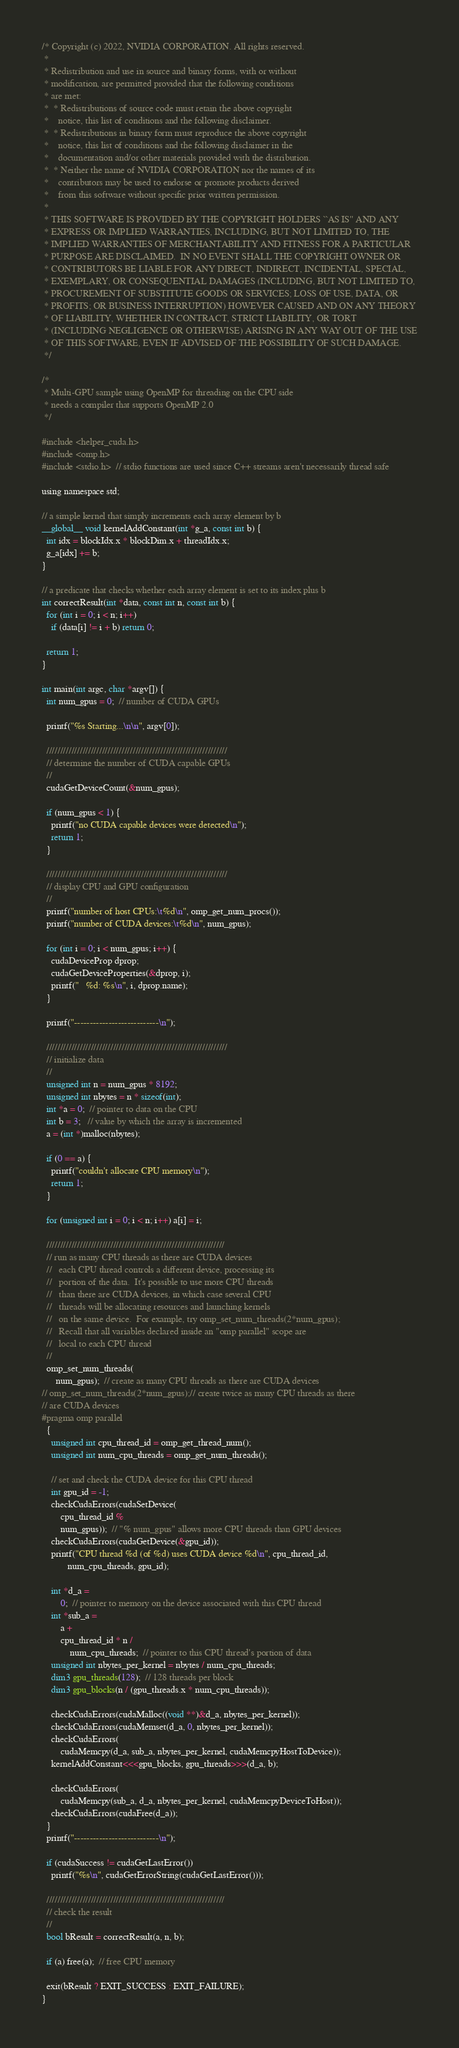<code> <loc_0><loc_0><loc_500><loc_500><_Cuda_>/* Copyright (c) 2022, NVIDIA CORPORATION. All rights reserved.
 *
 * Redistribution and use in source and binary forms, with or without
 * modification, are permitted provided that the following conditions
 * are met:
 *  * Redistributions of source code must retain the above copyright
 *    notice, this list of conditions and the following disclaimer.
 *  * Redistributions in binary form must reproduce the above copyright
 *    notice, this list of conditions and the following disclaimer in the
 *    documentation and/or other materials provided with the distribution.
 *  * Neither the name of NVIDIA CORPORATION nor the names of its
 *    contributors may be used to endorse or promote products derived
 *    from this software without specific prior written permission.
 *
 * THIS SOFTWARE IS PROVIDED BY THE COPYRIGHT HOLDERS ``AS IS'' AND ANY
 * EXPRESS OR IMPLIED WARRANTIES, INCLUDING, BUT NOT LIMITED TO, THE
 * IMPLIED WARRANTIES OF MERCHANTABILITY AND FITNESS FOR A PARTICULAR
 * PURPOSE ARE DISCLAIMED.  IN NO EVENT SHALL THE COPYRIGHT OWNER OR
 * CONTRIBUTORS BE LIABLE FOR ANY DIRECT, INDIRECT, INCIDENTAL, SPECIAL,
 * EXEMPLARY, OR CONSEQUENTIAL DAMAGES (INCLUDING, BUT NOT LIMITED TO,
 * PROCUREMENT OF SUBSTITUTE GOODS OR SERVICES; LOSS OF USE, DATA, OR
 * PROFITS; OR BUSINESS INTERRUPTION) HOWEVER CAUSED AND ON ANY THEORY
 * OF LIABILITY, WHETHER IN CONTRACT, STRICT LIABILITY, OR TORT
 * (INCLUDING NEGLIGENCE OR OTHERWISE) ARISING IN ANY WAY OUT OF THE USE
 * OF THIS SOFTWARE, EVEN IF ADVISED OF THE POSSIBILITY OF SUCH DAMAGE.
 */

/*
 * Multi-GPU sample using OpenMP for threading on the CPU side
 * needs a compiler that supports OpenMP 2.0
 */

#include <helper_cuda.h>
#include <omp.h>
#include <stdio.h>  // stdio functions are used since C++ streams aren't necessarily thread safe

using namespace std;

// a simple kernel that simply increments each array element by b
__global__ void kernelAddConstant(int *g_a, const int b) {
  int idx = blockIdx.x * blockDim.x + threadIdx.x;
  g_a[idx] += b;
}

// a predicate that checks whether each array element is set to its index plus b
int correctResult(int *data, const int n, const int b) {
  for (int i = 0; i < n; i++)
    if (data[i] != i + b) return 0;

  return 1;
}

int main(int argc, char *argv[]) {
  int num_gpus = 0;  // number of CUDA GPUs

  printf("%s Starting...\n\n", argv[0]);

  /////////////////////////////////////////////////////////////////
  // determine the number of CUDA capable GPUs
  //
  cudaGetDeviceCount(&num_gpus);

  if (num_gpus < 1) {
    printf("no CUDA capable devices were detected\n");
    return 1;
  }

  /////////////////////////////////////////////////////////////////
  // display CPU and GPU configuration
  //
  printf("number of host CPUs:\t%d\n", omp_get_num_procs());
  printf("number of CUDA devices:\t%d\n", num_gpus);

  for (int i = 0; i < num_gpus; i++) {
    cudaDeviceProp dprop;
    cudaGetDeviceProperties(&dprop, i);
    printf("   %d: %s\n", i, dprop.name);
  }

  printf("---------------------------\n");

  /////////////////////////////////////////////////////////////////
  // initialize data
  //
  unsigned int n = num_gpus * 8192;
  unsigned int nbytes = n * sizeof(int);
  int *a = 0;  // pointer to data on the CPU
  int b = 3;   // value by which the array is incremented
  a = (int *)malloc(nbytes);

  if (0 == a) {
    printf("couldn't allocate CPU memory\n");
    return 1;
  }

  for (unsigned int i = 0; i < n; i++) a[i] = i;

  ////////////////////////////////////////////////////////////////
  // run as many CPU threads as there are CUDA devices
  //   each CPU thread controls a different device, processing its
  //   portion of the data.  It's possible to use more CPU threads
  //   than there are CUDA devices, in which case several CPU
  //   threads will be allocating resources and launching kernels
  //   on the same device.  For example, try omp_set_num_threads(2*num_gpus);
  //   Recall that all variables declared inside an "omp parallel" scope are
  //   local to each CPU thread
  //
  omp_set_num_threads(
      num_gpus);  // create as many CPU threads as there are CUDA devices
// omp_set_num_threads(2*num_gpus);// create twice as many CPU threads as there
// are CUDA devices
#pragma omp parallel
  {
    unsigned int cpu_thread_id = omp_get_thread_num();
    unsigned int num_cpu_threads = omp_get_num_threads();

    // set and check the CUDA device for this CPU thread
    int gpu_id = -1;
    checkCudaErrors(cudaSetDevice(
        cpu_thread_id %
        num_gpus));  // "% num_gpus" allows more CPU threads than GPU devices
    checkCudaErrors(cudaGetDevice(&gpu_id));
    printf("CPU thread %d (of %d) uses CUDA device %d\n", cpu_thread_id,
           num_cpu_threads, gpu_id);

    int *d_a =
        0;  // pointer to memory on the device associated with this CPU thread
    int *sub_a =
        a +
        cpu_thread_id * n /
            num_cpu_threads;  // pointer to this CPU thread's portion of data
    unsigned int nbytes_per_kernel = nbytes / num_cpu_threads;
    dim3 gpu_threads(128);  // 128 threads per block
    dim3 gpu_blocks(n / (gpu_threads.x * num_cpu_threads));

    checkCudaErrors(cudaMalloc((void **)&d_a, nbytes_per_kernel));
    checkCudaErrors(cudaMemset(d_a, 0, nbytes_per_kernel));
    checkCudaErrors(
        cudaMemcpy(d_a, sub_a, nbytes_per_kernel, cudaMemcpyHostToDevice));
    kernelAddConstant<<<gpu_blocks, gpu_threads>>>(d_a, b);

    checkCudaErrors(
        cudaMemcpy(sub_a, d_a, nbytes_per_kernel, cudaMemcpyDeviceToHost));
    checkCudaErrors(cudaFree(d_a));
  }
  printf("---------------------------\n");

  if (cudaSuccess != cudaGetLastError())
    printf("%s\n", cudaGetErrorString(cudaGetLastError()));

  ////////////////////////////////////////////////////////////////
  // check the result
  //
  bool bResult = correctResult(a, n, b);

  if (a) free(a);  // free CPU memory

  exit(bResult ? EXIT_SUCCESS : EXIT_FAILURE);
}
</code> 